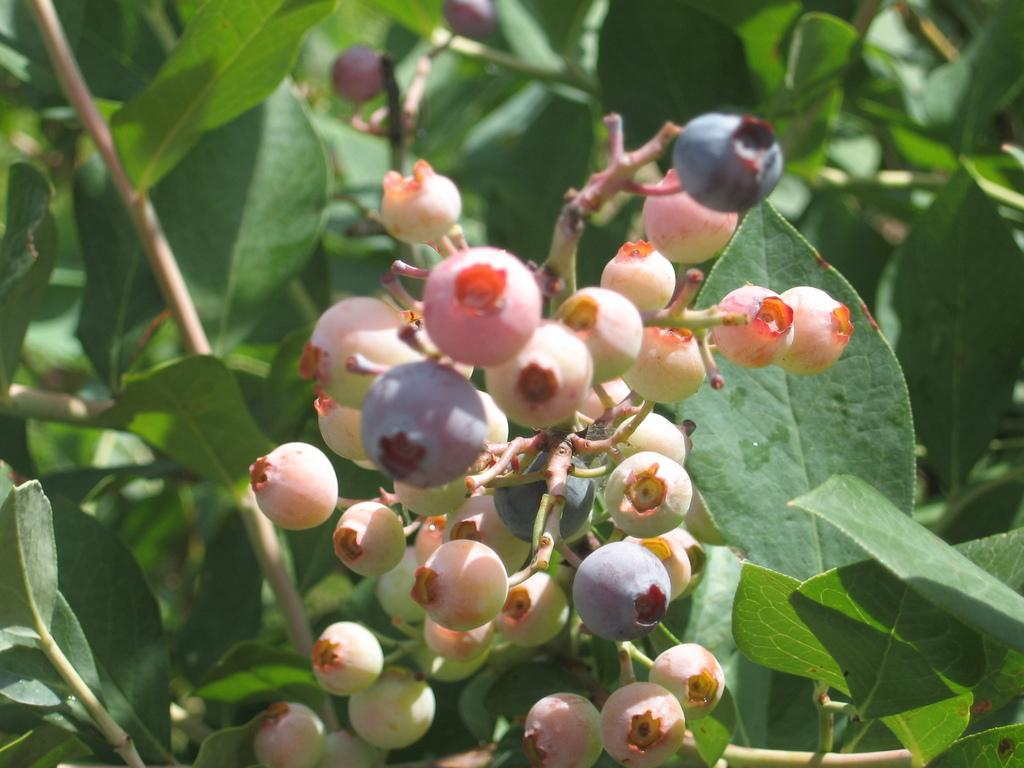What type of vegetation can be seen in the image? There are leaves in the image. What type of fruit is visible in the image? There is a bunch of berry fruits in the image. How are the berry fruits connected to each other? The berry fruits are attached to a stem. What type of meal is being prepared with the leaves and berry fruits in the image? There is no indication in the image that a meal is being prepared, nor are any cooking utensils or ingredients present. 